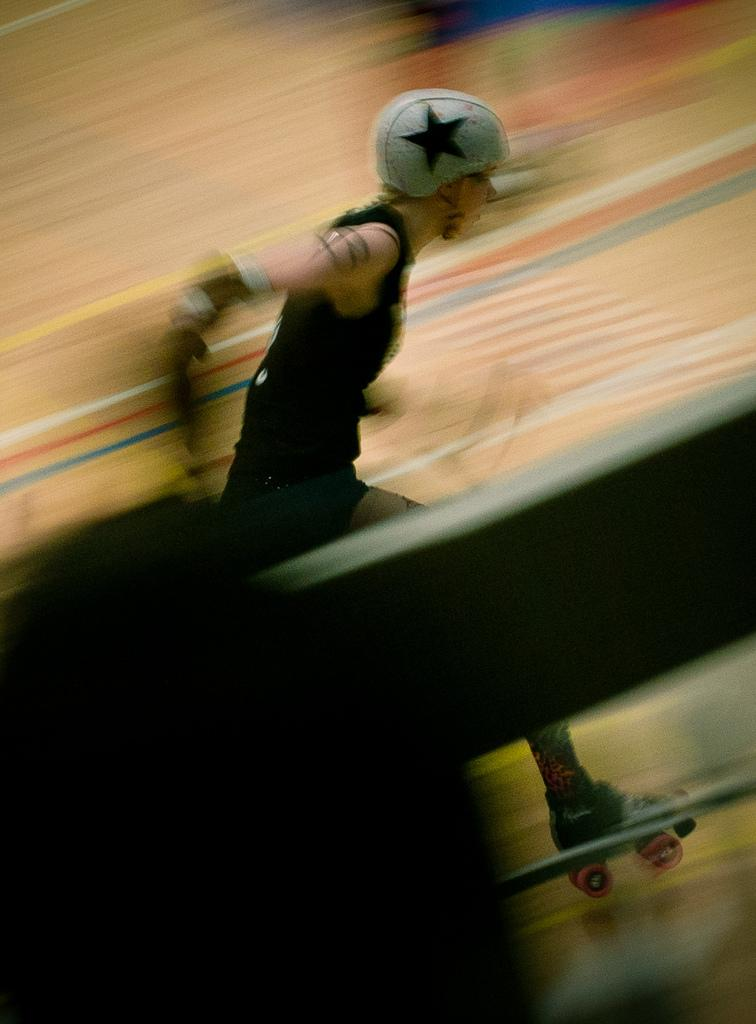Who or what is the main subject of the image? There is a person in the image. What type of protective gear is the person wearing? The person is wearing a helmet. What type of footwear is the person wearing? The person is wearing skate shoes. Can you describe the background of the image? The background of the image is blurred. What type of news is being reported by the oranges in the image? There are no oranges present in the image, and therefore no news can be reported by them. 